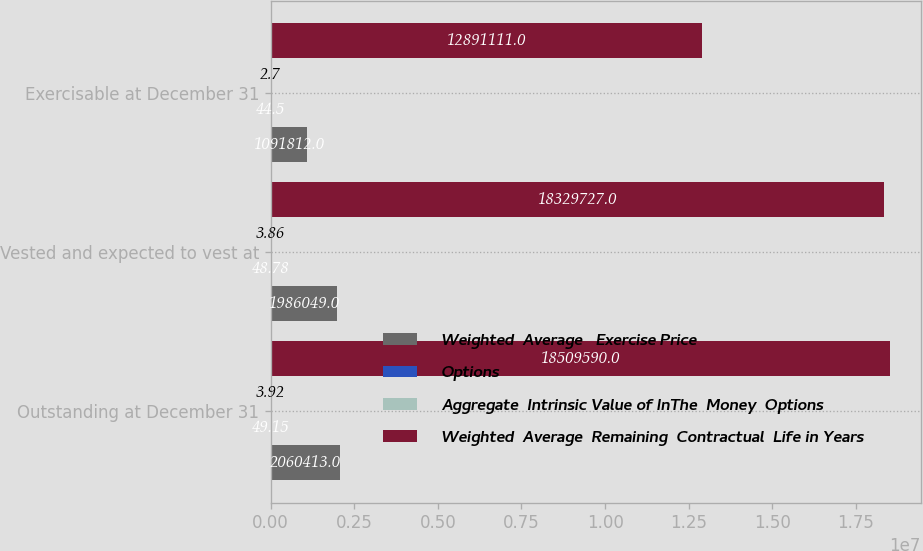Convert chart. <chart><loc_0><loc_0><loc_500><loc_500><stacked_bar_chart><ecel><fcel>Outstanding at December 31<fcel>Vested and expected to vest at<fcel>Exercisable at December 31<nl><fcel>Weighted  Average   Exercise Price<fcel>2.06041e+06<fcel>1.98605e+06<fcel>1.09181e+06<nl><fcel>Options<fcel>49.15<fcel>48.78<fcel>44.5<nl><fcel>Aggregate  Intrinsic Value of InThe  Money  Options<fcel>3.92<fcel>3.86<fcel>2.7<nl><fcel>Weighted  Average  Remaining  Contractual  Life in Years<fcel>1.85096e+07<fcel>1.83297e+07<fcel>1.28911e+07<nl></chart> 